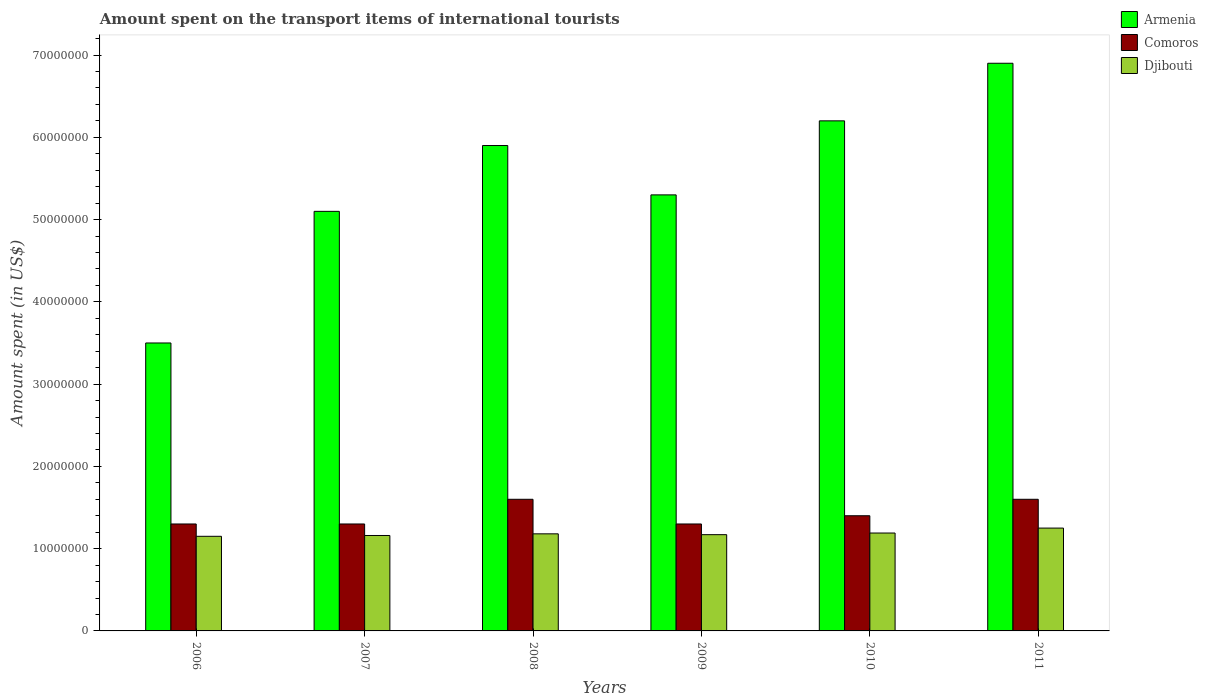How many groups of bars are there?
Provide a short and direct response. 6. Are the number of bars per tick equal to the number of legend labels?
Ensure brevity in your answer.  Yes. Are the number of bars on each tick of the X-axis equal?
Offer a terse response. Yes. How many bars are there on the 3rd tick from the right?
Give a very brief answer. 3. What is the label of the 2nd group of bars from the left?
Your answer should be very brief. 2007. What is the amount spent on the transport items of international tourists in Armenia in 2010?
Keep it short and to the point. 6.20e+07. Across all years, what is the maximum amount spent on the transport items of international tourists in Comoros?
Your response must be concise. 1.60e+07. Across all years, what is the minimum amount spent on the transport items of international tourists in Comoros?
Keep it short and to the point. 1.30e+07. In which year was the amount spent on the transport items of international tourists in Comoros maximum?
Provide a short and direct response. 2008. What is the total amount spent on the transport items of international tourists in Djibouti in the graph?
Keep it short and to the point. 7.10e+07. What is the difference between the amount spent on the transport items of international tourists in Djibouti in 2008 and that in 2009?
Make the answer very short. 1.00e+05. What is the difference between the amount spent on the transport items of international tourists in Armenia in 2011 and the amount spent on the transport items of international tourists in Comoros in 2008?
Provide a succinct answer. 5.30e+07. What is the average amount spent on the transport items of international tourists in Armenia per year?
Ensure brevity in your answer.  5.48e+07. In the year 2011, what is the difference between the amount spent on the transport items of international tourists in Armenia and amount spent on the transport items of international tourists in Comoros?
Give a very brief answer. 5.30e+07. In how many years, is the amount spent on the transport items of international tourists in Comoros greater than 56000000 US$?
Make the answer very short. 0. What is the ratio of the amount spent on the transport items of international tourists in Armenia in 2009 to that in 2011?
Offer a very short reply. 0.77. Is the difference between the amount spent on the transport items of international tourists in Armenia in 2009 and 2011 greater than the difference between the amount spent on the transport items of international tourists in Comoros in 2009 and 2011?
Keep it short and to the point. No. What is the difference between the highest and the second highest amount spent on the transport items of international tourists in Djibouti?
Offer a terse response. 6.00e+05. What is the difference between the highest and the lowest amount spent on the transport items of international tourists in Armenia?
Offer a very short reply. 3.40e+07. In how many years, is the amount spent on the transport items of international tourists in Comoros greater than the average amount spent on the transport items of international tourists in Comoros taken over all years?
Ensure brevity in your answer.  2. What does the 2nd bar from the left in 2008 represents?
Provide a succinct answer. Comoros. What does the 3rd bar from the right in 2006 represents?
Provide a short and direct response. Armenia. Is it the case that in every year, the sum of the amount spent on the transport items of international tourists in Djibouti and amount spent on the transport items of international tourists in Comoros is greater than the amount spent on the transport items of international tourists in Armenia?
Your response must be concise. No. How many bars are there?
Offer a very short reply. 18. How many years are there in the graph?
Provide a succinct answer. 6. What is the difference between two consecutive major ticks on the Y-axis?
Provide a short and direct response. 1.00e+07. Are the values on the major ticks of Y-axis written in scientific E-notation?
Provide a short and direct response. No. Does the graph contain any zero values?
Your answer should be compact. No. Does the graph contain grids?
Your answer should be compact. No. Where does the legend appear in the graph?
Offer a terse response. Top right. What is the title of the graph?
Keep it short and to the point. Amount spent on the transport items of international tourists. Does "Tuvalu" appear as one of the legend labels in the graph?
Provide a succinct answer. No. What is the label or title of the Y-axis?
Ensure brevity in your answer.  Amount spent (in US$). What is the Amount spent (in US$) of Armenia in 2006?
Your answer should be very brief. 3.50e+07. What is the Amount spent (in US$) in Comoros in 2006?
Your answer should be very brief. 1.30e+07. What is the Amount spent (in US$) of Djibouti in 2006?
Offer a very short reply. 1.15e+07. What is the Amount spent (in US$) in Armenia in 2007?
Provide a short and direct response. 5.10e+07. What is the Amount spent (in US$) of Comoros in 2007?
Your answer should be compact. 1.30e+07. What is the Amount spent (in US$) in Djibouti in 2007?
Ensure brevity in your answer.  1.16e+07. What is the Amount spent (in US$) in Armenia in 2008?
Your answer should be compact. 5.90e+07. What is the Amount spent (in US$) in Comoros in 2008?
Give a very brief answer. 1.60e+07. What is the Amount spent (in US$) in Djibouti in 2008?
Your answer should be very brief. 1.18e+07. What is the Amount spent (in US$) of Armenia in 2009?
Provide a short and direct response. 5.30e+07. What is the Amount spent (in US$) of Comoros in 2009?
Give a very brief answer. 1.30e+07. What is the Amount spent (in US$) of Djibouti in 2009?
Offer a terse response. 1.17e+07. What is the Amount spent (in US$) of Armenia in 2010?
Offer a terse response. 6.20e+07. What is the Amount spent (in US$) in Comoros in 2010?
Provide a succinct answer. 1.40e+07. What is the Amount spent (in US$) of Djibouti in 2010?
Keep it short and to the point. 1.19e+07. What is the Amount spent (in US$) in Armenia in 2011?
Provide a succinct answer. 6.90e+07. What is the Amount spent (in US$) in Comoros in 2011?
Your answer should be very brief. 1.60e+07. What is the Amount spent (in US$) of Djibouti in 2011?
Your answer should be compact. 1.25e+07. Across all years, what is the maximum Amount spent (in US$) in Armenia?
Offer a very short reply. 6.90e+07. Across all years, what is the maximum Amount spent (in US$) of Comoros?
Provide a succinct answer. 1.60e+07. Across all years, what is the maximum Amount spent (in US$) of Djibouti?
Give a very brief answer. 1.25e+07. Across all years, what is the minimum Amount spent (in US$) in Armenia?
Keep it short and to the point. 3.50e+07. Across all years, what is the minimum Amount spent (in US$) in Comoros?
Provide a succinct answer. 1.30e+07. Across all years, what is the minimum Amount spent (in US$) of Djibouti?
Provide a succinct answer. 1.15e+07. What is the total Amount spent (in US$) in Armenia in the graph?
Ensure brevity in your answer.  3.29e+08. What is the total Amount spent (in US$) of Comoros in the graph?
Ensure brevity in your answer.  8.50e+07. What is the total Amount spent (in US$) in Djibouti in the graph?
Your answer should be compact. 7.10e+07. What is the difference between the Amount spent (in US$) in Armenia in 2006 and that in 2007?
Keep it short and to the point. -1.60e+07. What is the difference between the Amount spent (in US$) in Armenia in 2006 and that in 2008?
Offer a very short reply. -2.40e+07. What is the difference between the Amount spent (in US$) in Djibouti in 2006 and that in 2008?
Offer a terse response. -3.00e+05. What is the difference between the Amount spent (in US$) of Armenia in 2006 and that in 2009?
Your answer should be compact. -1.80e+07. What is the difference between the Amount spent (in US$) of Djibouti in 2006 and that in 2009?
Ensure brevity in your answer.  -2.00e+05. What is the difference between the Amount spent (in US$) of Armenia in 2006 and that in 2010?
Offer a very short reply. -2.70e+07. What is the difference between the Amount spent (in US$) in Comoros in 2006 and that in 2010?
Your answer should be compact. -1.00e+06. What is the difference between the Amount spent (in US$) in Djibouti in 2006 and that in 2010?
Provide a succinct answer. -4.00e+05. What is the difference between the Amount spent (in US$) in Armenia in 2006 and that in 2011?
Provide a succinct answer. -3.40e+07. What is the difference between the Amount spent (in US$) in Comoros in 2006 and that in 2011?
Offer a very short reply. -3.00e+06. What is the difference between the Amount spent (in US$) in Djibouti in 2006 and that in 2011?
Offer a very short reply. -1.00e+06. What is the difference between the Amount spent (in US$) of Armenia in 2007 and that in 2008?
Offer a very short reply. -8.00e+06. What is the difference between the Amount spent (in US$) of Comoros in 2007 and that in 2008?
Your response must be concise. -3.00e+06. What is the difference between the Amount spent (in US$) in Armenia in 2007 and that in 2009?
Ensure brevity in your answer.  -2.00e+06. What is the difference between the Amount spent (in US$) in Comoros in 2007 and that in 2009?
Provide a short and direct response. 0. What is the difference between the Amount spent (in US$) of Armenia in 2007 and that in 2010?
Make the answer very short. -1.10e+07. What is the difference between the Amount spent (in US$) in Comoros in 2007 and that in 2010?
Offer a very short reply. -1.00e+06. What is the difference between the Amount spent (in US$) in Djibouti in 2007 and that in 2010?
Give a very brief answer. -3.00e+05. What is the difference between the Amount spent (in US$) in Armenia in 2007 and that in 2011?
Offer a very short reply. -1.80e+07. What is the difference between the Amount spent (in US$) in Djibouti in 2007 and that in 2011?
Provide a succinct answer. -9.00e+05. What is the difference between the Amount spent (in US$) of Comoros in 2008 and that in 2009?
Make the answer very short. 3.00e+06. What is the difference between the Amount spent (in US$) in Djibouti in 2008 and that in 2009?
Make the answer very short. 1.00e+05. What is the difference between the Amount spent (in US$) of Armenia in 2008 and that in 2011?
Your response must be concise. -1.00e+07. What is the difference between the Amount spent (in US$) in Djibouti in 2008 and that in 2011?
Your answer should be very brief. -7.00e+05. What is the difference between the Amount spent (in US$) in Armenia in 2009 and that in 2010?
Your answer should be compact. -9.00e+06. What is the difference between the Amount spent (in US$) of Armenia in 2009 and that in 2011?
Ensure brevity in your answer.  -1.60e+07. What is the difference between the Amount spent (in US$) in Comoros in 2009 and that in 2011?
Offer a very short reply. -3.00e+06. What is the difference between the Amount spent (in US$) in Djibouti in 2009 and that in 2011?
Your answer should be very brief. -8.00e+05. What is the difference between the Amount spent (in US$) in Armenia in 2010 and that in 2011?
Offer a very short reply. -7.00e+06. What is the difference between the Amount spent (in US$) in Djibouti in 2010 and that in 2011?
Your response must be concise. -6.00e+05. What is the difference between the Amount spent (in US$) of Armenia in 2006 and the Amount spent (in US$) of Comoros in 2007?
Your answer should be compact. 2.20e+07. What is the difference between the Amount spent (in US$) in Armenia in 2006 and the Amount spent (in US$) in Djibouti in 2007?
Offer a very short reply. 2.34e+07. What is the difference between the Amount spent (in US$) in Comoros in 2006 and the Amount spent (in US$) in Djibouti in 2007?
Your response must be concise. 1.40e+06. What is the difference between the Amount spent (in US$) in Armenia in 2006 and the Amount spent (in US$) in Comoros in 2008?
Your answer should be compact. 1.90e+07. What is the difference between the Amount spent (in US$) in Armenia in 2006 and the Amount spent (in US$) in Djibouti in 2008?
Provide a succinct answer. 2.32e+07. What is the difference between the Amount spent (in US$) of Comoros in 2006 and the Amount spent (in US$) of Djibouti in 2008?
Provide a short and direct response. 1.20e+06. What is the difference between the Amount spent (in US$) in Armenia in 2006 and the Amount spent (in US$) in Comoros in 2009?
Offer a terse response. 2.20e+07. What is the difference between the Amount spent (in US$) of Armenia in 2006 and the Amount spent (in US$) of Djibouti in 2009?
Offer a very short reply. 2.33e+07. What is the difference between the Amount spent (in US$) in Comoros in 2006 and the Amount spent (in US$) in Djibouti in 2009?
Offer a very short reply. 1.30e+06. What is the difference between the Amount spent (in US$) in Armenia in 2006 and the Amount spent (in US$) in Comoros in 2010?
Offer a terse response. 2.10e+07. What is the difference between the Amount spent (in US$) in Armenia in 2006 and the Amount spent (in US$) in Djibouti in 2010?
Give a very brief answer. 2.31e+07. What is the difference between the Amount spent (in US$) in Comoros in 2006 and the Amount spent (in US$) in Djibouti in 2010?
Provide a succinct answer. 1.10e+06. What is the difference between the Amount spent (in US$) in Armenia in 2006 and the Amount spent (in US$) in Comoros in 2011?
Ensure brevity in your answer.  1.90e+07. What is the difference between the Amount spent (in US$) of Armenia in 2006 and the Amount spent (in US$) of Djibouti in 2011?
Make the answer very short. 2.25e+07. What is the difference between the Amount spent (in US$) of Armenia in 2007 and the Amount spent (in US$) of Comoros in 2008?
Give a very brief answer. 3.50e+07. What is the difference between the Amount spent (in US$) in Armenia in 2007 and the Amount spent (in US$) in Djibouti in 2008?
Offer a very short reply. 3.92e+07. What is the difference between the Amount spent (in US$) of Comoros in 2007 and the Amount spent (in US$) of Djibouti in 2008?
Offer a terse response. 1.20e+06. What is the difference between the Amount spent (in US$) of Armenia in 2007 and the Amount spent (in US$) of Comoros in 2009?
Give a very brief answer. 3.80e+07. What is the difference between the Amount spent (in US$) of Armenia in 2007 and the Amount spent (in US$) of Djibouti in 2009?
Keep it short and to the point. 3.93e+07. What is the difference between the Amount spent (in US$) of Comoros in 2007 and the Amount spent (in US$) of Djibouti in 2009?
Your response must be concise. 1.30e+06. What is the difference between the Amount spent (in US$) of Armenia in 2007 and the Amount spent (in US$) of Comoros in 2010?
Ensure brevity in your answer.  3.70e+07. What is the difference between the Amount spent (in US$) in Armenia in 2007 and the Amount spent (in US$) in Djibouti in 2010?
Provide a succinct answer. 3.91e+07. What is the difference between the Amount spent (in US$) of Comoros in 2007 and the Amount spent (in US$) of Djibouti in 2010?
Your response must be concise. 1.10e+06. What is the difference between the Amount spent (in US$) of Armenia in 2007 and the Amount spent (in US$) of Comoros in 2011?
Your answer should be compact. 3.50e+07. What is the difference between the Amount spent (in US$) of Armenia in 2007 and the Amount spent (in US$) of Djibouti in 2011?
Provide a short and direct response. 3.85e+07. What is the difference between the Amount spent (in US$) of Armenia in 2008 and the Amount spent (in US$) of Comoros in 2009?
Your answer should be compact. 4.60e+07. What is the difference between the Amount spent (in US$) of Armenia in 2008 and the Amount spent (in US$) of Djibouti in 2009?
Ensure brevity in your answer.  4.73e+07. What is the difference between the Amount spent (in US$) in Comoros in 2008 and the Amount spent (in US$) in Djibouti in 2009?
Keep it short and to the point. 4.30e+06. What is the difference between the Amount spent (in US$) of Armenia in 2008 and the Amount spent (in US$) of Comoros in 2010?
Your answer should be compact. 4.50e+07. What is the difference between the Amount spent (in US$) in Armenia in 2008 and the Amount spent (in US$) in Djibouti in 2010?
Keep it short and to the point. 4.71e+07. What is the difference between the Amount spent (in US$) of Comoros in 2008 and the Amount spent (in US$) of Djibouti in 2010?
Ensure brevity in your answer.  4.10e+06. What is the difference between the Amount spent (in US$) in Armenia in 2008 and the Amount spent (in US$) in Comoros in 2011?
Your answer should be compact. 4.30e+07. What is the difference between the Amount spent (in US$) of Armenia in 2008 and the Amount spent (in US$) of Djibouti in 2011?
Provide a succinct answer. 4.65e+07. What is the difference between the Amount spent (in US$) of Comoros in 2008 and the Amount spent (in US$) of Djibouti in 2011?
Make the answer very short. 3.50e+06. What is the difference between the Amount spent (in US$) of Armenia in 2009 and the Amount spent (in US$) of Comoros in 2010?
Provide a short and direct response. 3.90e+07. What is the difference between the Amount spent (in US$) in Armenia in 2009 and the Amount spent (in US$) in Djibouti in 2010?
Offer a terse response. 4.11e+07. What is the difference between the Amount spent (in US$) of Comoros in 2009 and the Amount spent (in US$) of Djibouti in 2010?
Ensure brevity in your answer.  1.10e+06. What is the difference between the Amount spent (in US$) of Armenia in 2009 and the Amount spent (in US$) of Comoros in 2011?
Give a very brief answer. 3.70e+07. What is the difference between the Amount spent (in US$) in Armenia in 2009 and the Amount spent (in US$) in Djibouti in 2011?
Provide a succinct answer. 4.05e+07. What is the difference between the Amount spent (in US$) of Comoros in 2009 and the Amount spent (in US$) of Djibouti in 2011?
Offer a very short reply. 5.00e+05. What is the difference between the Amount spent (in US$) in Armenia in 2010 and the Amount spent (in US$) in Comoros in 2011?
Provide a succinct answer. 4.60e+07. What is the difference between the Amount spent (in US$) in Armenia in 2010 and the Amount spent (in US$) in Djibouti in 2011?
Make the answer very short. 4.95e+07. What is the difference between the Amount spent (in US$) of Comoros in 2010 and the Amount spent (in US$) of Djibouti in 2011?
Give a very brief answer. 1.50e+06. What is the average Amount spent (in US$) in Armenia per year?
Make the answer very short. 5.48e+07. What is the average Amount spent (in US$) in Comoros per year?
Your answer should be very brief. 1.42e+07. What is the average Amount spent (in US$) of Djibouti per year?
Provide a short and direct response. 1.18e+07. In the year 2006, what is the difference between the Amount spent (in US$) in Armenia and Amount spent (in US$) in Comoros?
Provide a succinct answer. 2.20e+07. In the year 2006, what is the difference between the Amount spent (in US$) of Armenia and Amount spent (in US$) of Djibouti?
Keep it short and to the point. 2.35e+07. In the year 2006, what is the difference between the Amount spent (in US$) in Comoros and Amount spent (in US$) in Djibouti?
Your response must be concise. 1.50e+06. In the year 2007, what is the difference between the Amount spent (in US$) of Armenia and Amount spent (in US$) of Comoros?
Give a very brief answer. 3.80e+07. In the year 2007, what is the difference between the Amount spent (in US$) of Armenia and Amount spent (in US$) of Djibouti?
Give a very brief answer. 3.94e+07. In the year 2007, what is the difference between the Amount spent (in US$) in Comoros and Amount spent (in US$) in Djibouti?
Provide a succinct answer. 1.40e+06. In the year 2008, what is the difference between the Amount spent (in US$) of Armenia and Amount spent (in US$) of Comoros?
Keep it short and to the point. 4.30e+07. In the year 2008, what is the difference between the Amount spent (in US$) in Armenia and Amount spent (in US$) in Djibouti?
Give a very brief answer. 4.72e+07. In the year 2008, what is the difference between the Amount spent (in US$) of Comoros and Amount spent (in US$) of Djibouti?
Your response must be concise. 4.20e+06. In the year 2009, what is the difference between the Amount spent (in US$) of Armenia and Amount spent (in US$) of Comoros?
Offer a very short reply. 4.00e+07. In the year 2009, what is the difference between the Amount spent (in US$) of Armenia and Amount spent (in US$) of Djibouti?
Offer a very short reply. 4.13e+07. In the year 2009, what is the difference between the Amount spent (in US$) in Comoros and Amount spent (in US$) in Djibouti?
Your response must be concise. 1.30e+06. In the year 2010, what is the difference between the Amount spent (in US$) in Armenia and Amount spent (in US$) in Comoros?
Offer a terse response. 4.80e+07. In the year 2010, what is the difference between the Amount spent (in US$) in Armenia and Amount spent (in US$) in Djibouti?
Give a very brief answer. 5.01e+07. In the year 2010, what is the difference between the Amount spent (in US$) in Comoros and Amount spent (in US$) in Djibouti?
Your answer should be compact. 2.10e+06. In the year 2011, what is the difference between the Amount spent (in US$) of Armenia and Amount spent (in US$) of Comoros?
Give a very brief answer. 5.30e+07. In the year 2011, what is the difference between the Amount spent (in US$) of Armenia and Amount spent (in US$) of Djibouti?
Provide a short and direct response. 5.65e+07. In the year 2011, what is the difference between the Amount spent (in US$) of Comoros and Amount spent (in US$) of Djibouti?
Make the answer very short. 3.50e+06. What is the ratio of the Amount spent (in US$) in Armenia in 2006 to that in 2007?
Ensure brevity in your answer.  0.69. What is the ratio of the Amount spent (in US$) in Comoros in 2006 to that in 2007?
Your response must be concise. 1. What is the ratio of the Amount spent (in US$) in Djibouti in 2006 to that in 2007?
Give a very brief answer. 0.99. What is the ratio of the Amount spent (in US$) in Armenia in 2006 to that in 2008?
Give a very brief answer. 0.59. What is the ratio of the Amount spent (in US$) of Comoros in 2006 to that in 2008?
Offer a very short reply. 0.81. What is the ratio of the Amount spent (in US$) of Djibouti in 2006 to that in 2008?
Make the answer very short. 0.97. What is the ratio of the Amount spent (in US$) of Armenia in 2006 to that in 2009?
Offer a very short reply. 0.66. What is the ratio of the Amount spent (in US$) in Comoros in 2006 to that in 2009?
Offer a very short reply. 1. What is the ratio of the Amount spent (in US$) in Djibouti in 2006 to that in 2009?
Give a very brief answer. 0.98. What is the ratio of the Amount spent (in US$) in Armenia in 2006 to that in 2010?
Your response must be concise. 0.56. What is the ratio of the Amount spent (in US$) in Djibouti in 2006 to that in 2010?
Provide a short and direct response. 0.97. What is the ratio of the Amount spent (in US$) in Armenia in 2006 to that in 2011?
Make the answer very short. 0.51. What is the ratio of the Amount spent (in US$) of Comoros in 2006 to that in 2011?
Offer a very short reply. 0.81. What is the ratio of the Amount spent (in US$) of Armenia in 2007 to that in 2008?
Give a very brief answer. 0.86. What is the ratio of the Amount spent (in US$) in Comoros in 2007 to that in 2008?
Your answer should be compact. 0.81. What is the ratio of the Amount spent (in US$) in Djibouti in 2007 to that in 2008?
Provide a succinct answer. 0.98. What is the ratio of the Amount spent (in US$) of Armenia in 2007 to that in 2009?
Provide a short and direct response. 0.96. What is the ratio of the Amount spent (in US$) in Comoros in 2007 to that in 2009?
Give a very brief answer. 1. What is the ratio of the Amount spent (in US$) in Djibouti in 2007 to that in 2009?
Offer a very short reply. 0.99. What is the ratio of the Amount spent (in US$) of Armenia in 2007 to that in 2010?
Make the answer very short. 0.82. What is the ratio of the Amount spent (in US$) in Djibouti in 2007 to that in 2010?
Offer a very short reply. 0.97. What is the ratio of the Amount spent (in US$) in Armenia in 2007 to that in 2011?
Give a very brief answer. 0.74. What is the ratio of the Amount spent (in US$) in Comoros in 2007 to that in 2011?
Ensure brevity in your answer.  0.81. What is the ratio of the Amount spent (in US$) of Djibouti in 2007 to that in 2011?
Provide a succinct answer. 0.93. What is the ratio of the Amount spent (in US$) in Armenia in 2008 to that in 2009?
Give a very brief answer. 1.11. What is the ratio of the Amount spent (in US$) of Comoros in 2008 to that in 2009?
Offer a terse response. 1.23. What is the ratio of the Amount spent (in US$) in Djibouti in 2008 to that in 2009?
Offer a very short reply. 1.01. What is the ratio of the Amount spent (in US$) in Armenia in 2008 to that in 2010?
Your response must be concise. 0.95. What is the ratio of the Amount spent (in US$) in Comoros in 2008 to that in 2010?
Provide a succinct answer. 1.14. What is the ratio of the Amount spent (in US$) in Armenia in 2008 to that in 2011?
Your response must be concise. 0.86. What is the ratio of the Amount spent (in US$) of Comoros in 2008 to that in 2011?
Your answer should be compact. 1. What is the ratio of the Amount spent (in US$) of Djibouti in 2008 to that in 2011?
Give a very brief answer. 0.94. What is the ratio of the Amount spent (in US$) of Armenia in 2009 to that in 2010?
Provide a succinct answer. 0.85. What is the ratio of the Amount spent (in US$) of Comoros in 2009 to that in 2010?
Provide a short and direct response. 0.93. What is the ratio of the Amount spent (in US$) of Djibouti in 2009 to that in 2010?
Keep it short and to the point. 0.98. What is the ratio of the Amount spent (in US$) in Armenia in 2009 to that in 2011?
Keep it short and to the point. 0.77. What is the ratio of the Amount spent (in US$) in Comoros in 2009 to that in 2011?
Your answer should be compact. 0.81. What is the ratio of the Amount spent (in US$) in Djibouti in 2009 to that in 2011?
Provide a succinct answer. 0.94. What is the ratio of the Amount spent (in US$) in Armenia in 2010 to that in 2011?
Your response must be concise. 0.9. What is the difference between the highest and the second highest Amount spent (in US$) of Armenia?
Provide a succinct answer. 7.00e+06. What is the difference between the highest and the second highest Amount spent (in US$) of Comoros?
Your answer should be very brief. 0. What is the difference between the highest and the second highest Amount spent (in US$) of Djibouti?
Your answer should be compact. 6.00e+05. What is the difference between the highest and the lowest Amount spent (in US$) of Armenia?
Give a very brief answer. 3.40e+07. What is the difference between the highest and the lowest Amount spent (in US$) of Comoros?
Offer a very short reply. 3.00e+06. 